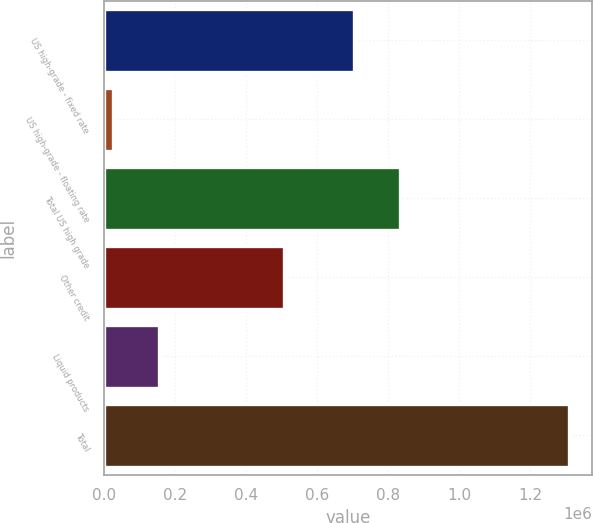Convert chart to OTSL. <chart><loc_0><loc_0><loc_500><loc_500><bar_chart><fcel>US high-grade - fixed rate<fcel>US high-grade - floating rate<fcel>Total US high grade<fcel>Other credit<fcel>Liquid products<fcel>Total<nl><fcel>704648<fcel>25917<fcel>832926<fcel>506762<fcel>154196<fcel>1.3087e+06<nl></chart> 